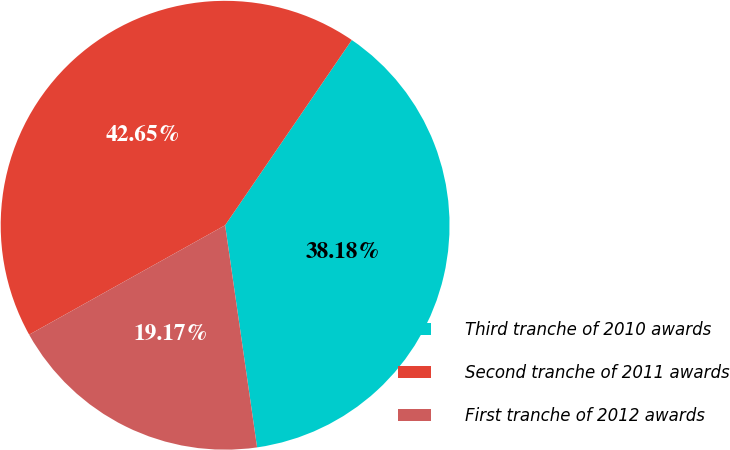Convert chart. <chart><loc_0><loc_0><loc_500><loc_500><pie_chart><fcel>Third tranche of 2010 awards<fcel>Second tranche of 2011 awards<fcel>First tranche of 2012 awards<nl><fcel>38.18%<fcel>42.65%<fcel>19.17%<nl></chart> 